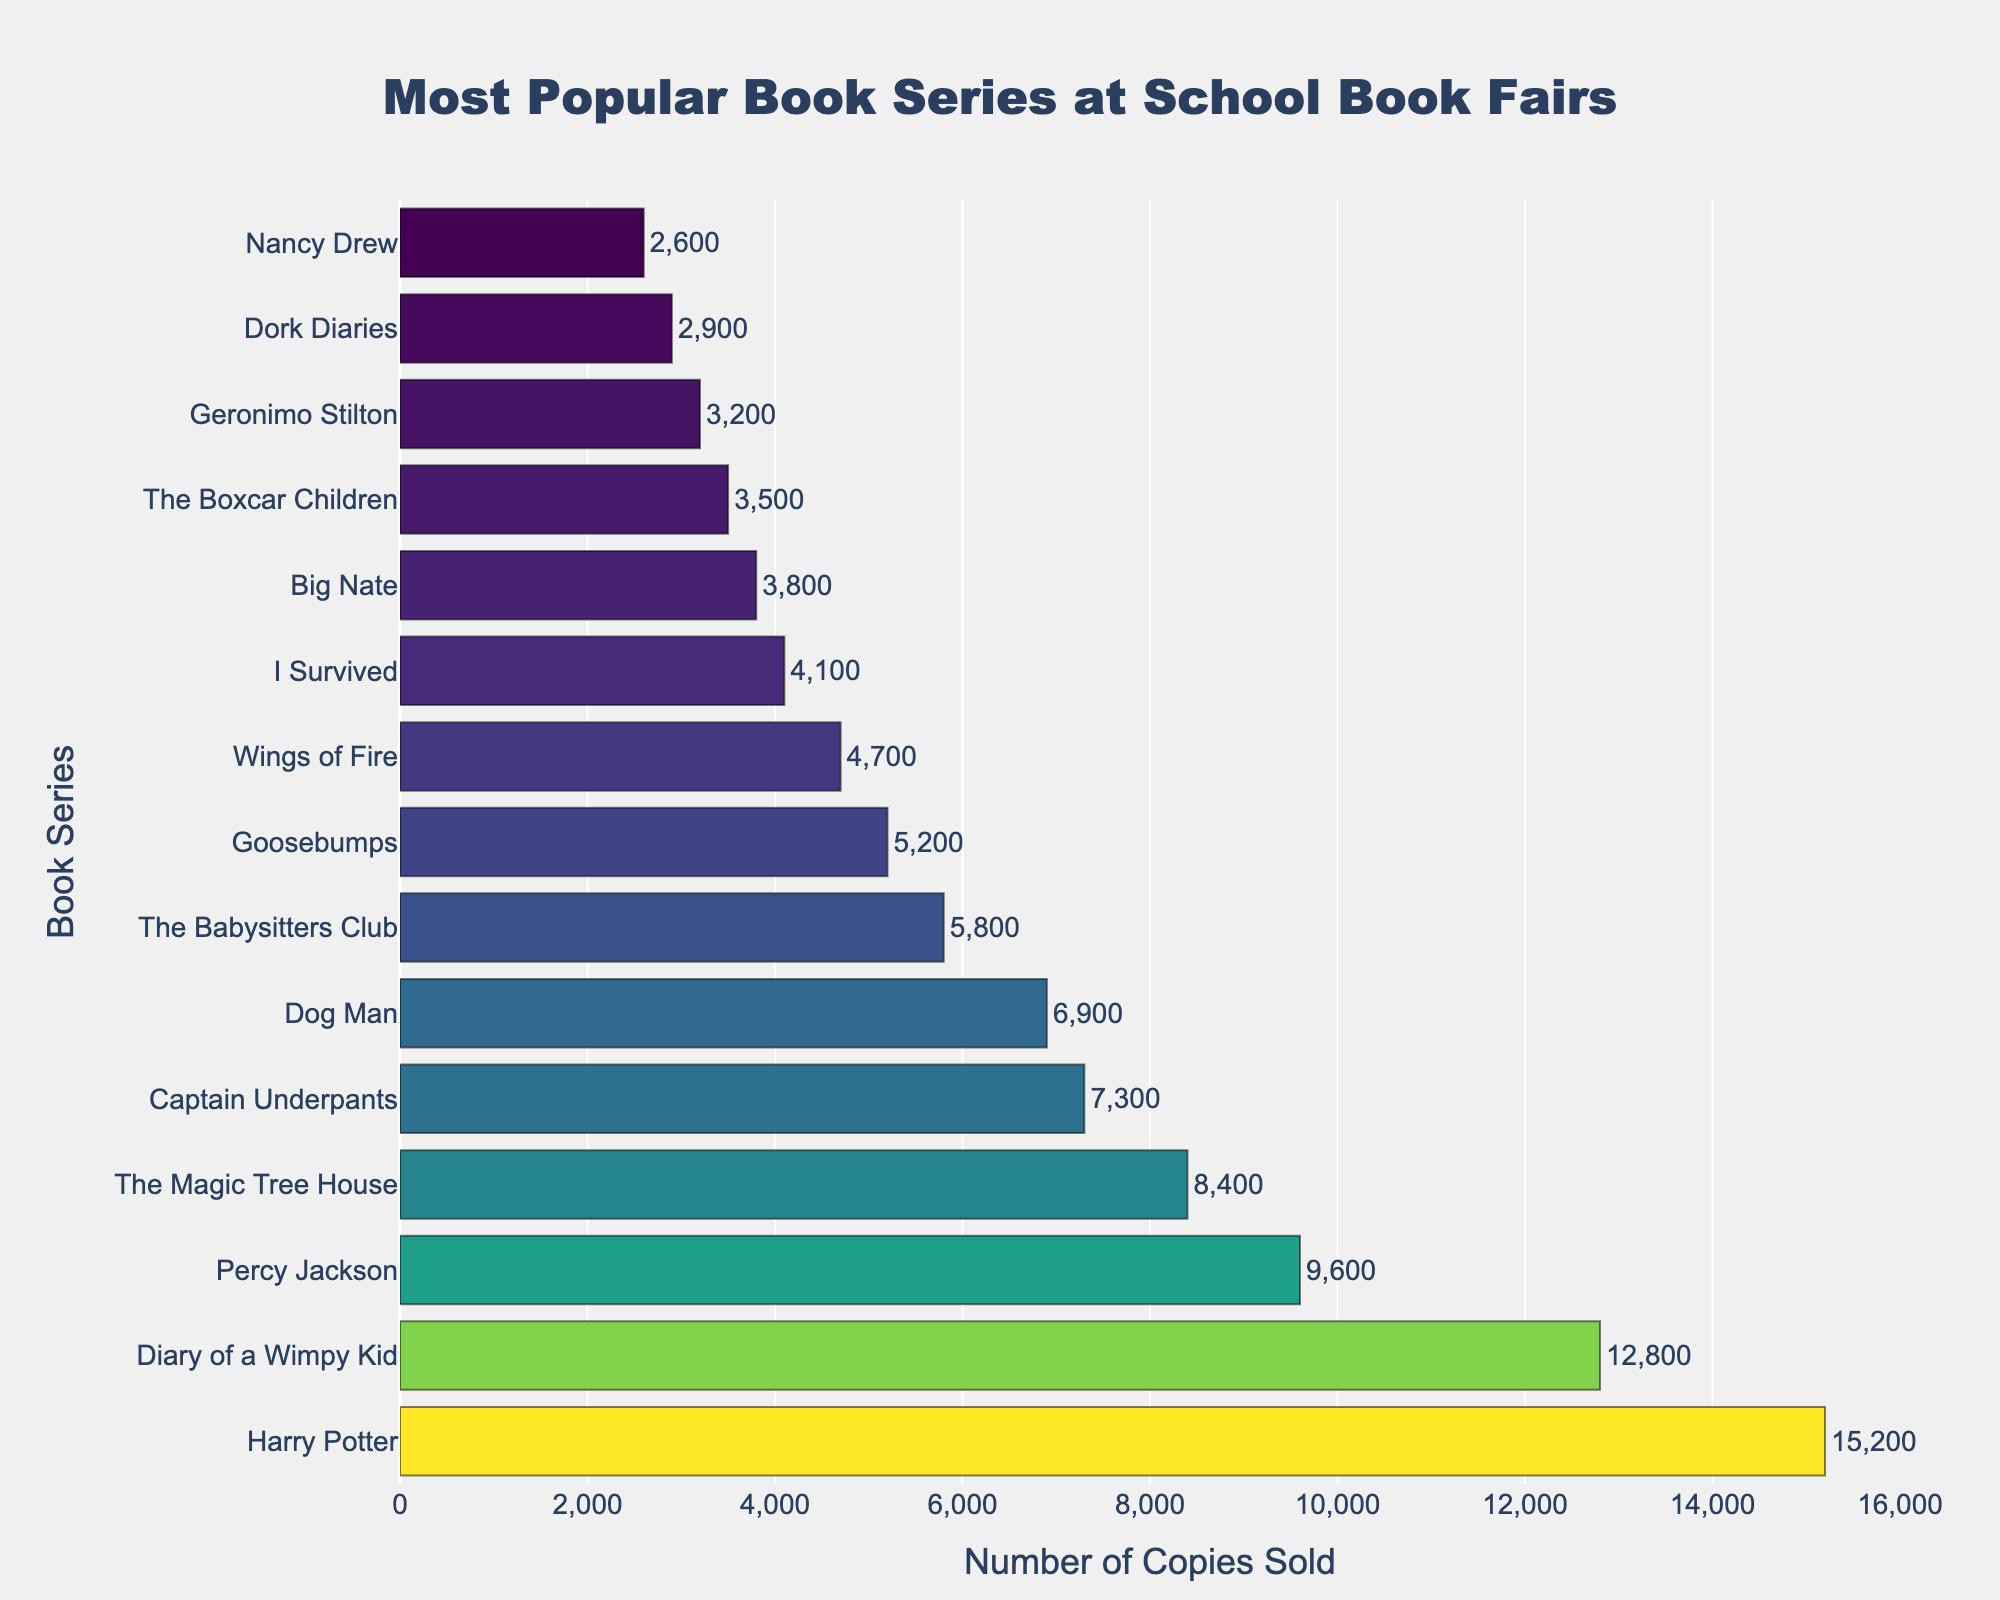Which book series has the highest number of copies sold? The bar representing "Harry Potter" is the longest, indicating it has the highest number of copies sold.
Answer: Harry Potter Which book series has the lowest number of copies sold? The bar representing "Nancy Drew" is the shortest, indicating it has the lowest number of copies sold.
Answer: Nancy Drew How many more copies did "Harry Potter" sell compared to "Diary of a Wimpy Kid"? "Harry Potter" sold 15,200 copies and "Diary of a Wimpy Kid" sold 12,800 copies. The difference is 15,200 - 12,800 = 2,400 copies.
Answer: 2,400 Which series sold fewer copies: "Percy Jackson" or "The Magic Tree House"? The bar for "Percy Jackson" is longer than that for "The Magic Tree House," indicating that "The Magic Tree House" sold fewer copies.
Answer: The Magic Tree House What is the total number of copies sold by the top three book series? Summing the copies sold by "Harry Potter," "Diary of a Wimpy Kid," and "Percy Jackson": 15,200 + 12,800 + 9,600 = 37,600.
Answer: 37,600 Which book series sold more than 7,000 but fewer than 10,000 copies? The bars for "Percy Jackson," "The Magic Tree House," and "Captain Underpants" fall in this range.
Answer: Percy Jackson, The Magic Tree House, Captain Underpants How many copies did "Dog Man" and "The Babysitters Club" sell combined? "Dog Man" sold 6,900 copies, and "The Babysitters Club" sold 5,800 copies. Their combined total is 6,900 + 5,800 = 12,700 copies.
Answer: 12,700 What is the average number of copies sold among the bottom five book series? Adding the copies sold of "The Boxcar Children," "Geronimo Stilton," "Dork Diaries," "Nancy Drew," and "I Survived": 3,500 + 3,200 + 2,900 + 2,600 + 4,100 = 16,300. The average is 16,300/5 = 3,260.
Answer: 3,260 Which two book series have the closest number of copies sold? "The Boxcar Children" sold 3,500 copies, and "Geronimo Stilton" sold 3,200 copies. The difference is minimal compared to others: 3,500 - 3,200 = 300.
Answer: The Boxcar Children and Geronimo Stilton How many series sold more than 4,000 copies but less than 10,000 copies? Counting the bars within this range: "Percy Jackson," "The Magic Tree House," "Captain Underpants," "Dog Man," "The Babysitters Club," and "Goosebumps." So, there are six series.
Answer: 6 